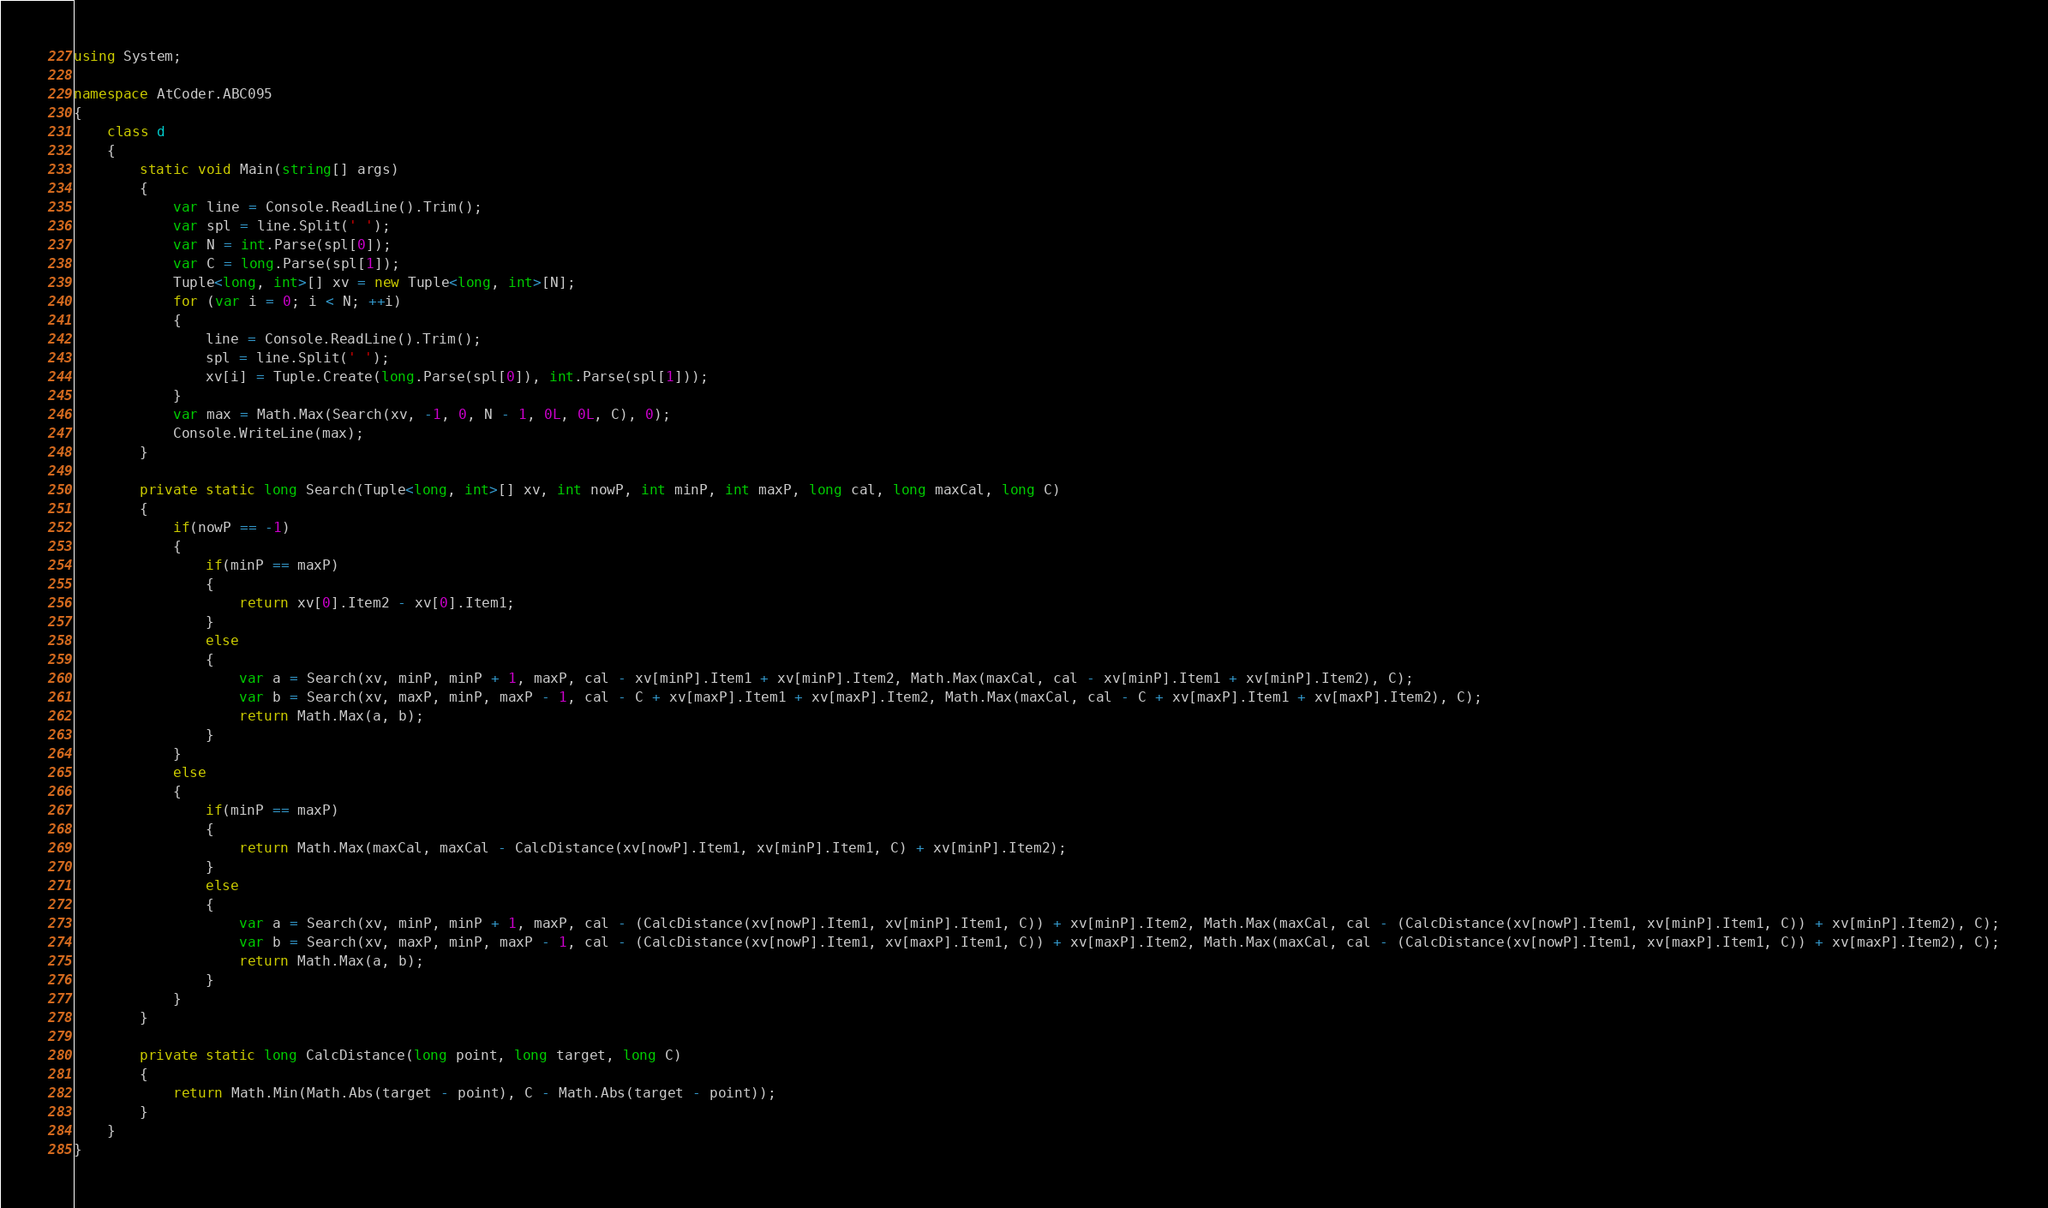<code> <loc_0><loc_0><loc_500><loc_500><_C#_>using System;

namespace AtCoder.ABC095
{
    class d
    {
        static void Main(string[] args)
        {
            var line = Console.ReadLine().Trim();
            var spl = line.Split(' ');
            var N = int.Parse(spl[0]);
            var C = long.Parse(spl[1]);
            Tuple<long, int>[] xv = new Tuple<long, int>[N];
            for (var i = 0; i < N; ++i)
            {
                line = Console.ReadLine().Trim();
                spl = line.Split(' ');
                xv[i] = Tuple.Create(long.Parse(spl[0]), int.Parse(spl[1]));
            }
            var max = Math.Max(Search(xv, -1, 0, N - 1, 0L, 0L, C), 0);
            Console.WriteLine(max);
        }

        private static long Search(Tuple<long, int>[] xv, int nowP, int minP, int maxP, long cal, long maxCal, long C)
        {
            if(nowP == -1)
            {
                if(minP == maxP)
                {
                    return xv[0].Item2 - xv[0].Item1;
                }
                else
                {
                    var a = Search(xv, minP, minP + 1, maxP, cal - xv[minP].Item1 + xv[minP].Item2, Math.Max(maxCal, cal - xv[minP].Item1 + xv[minP].Item2), C);
                    var b = Search(xv, maxP, minP, maxP - 1, cal - C + xv[maxP].Item1 + xv[maxP].Item2, Math.Max(maxCal, cal - C + xv[maxP].Item1 + xv[maxP].Item2), C);
                    return Math.Max(a, b);
                }
            }
            else
            {
                if(minP == maxP)
                {
                    return Math.Max(maxCal, maxCal - CalcDistance(xv[nowP].Item1, xv[minP].Item1, C) + xv[minP].Item2);
                }
                else
                {
                    var a = Search(xv, minP, minP + 1, maxP, cal - (CalcDistance(xv[nowP].Item1, xv[minP].Item1, C)) + xv[minP].Item2, Math.Max(maxCal, cal - (CalcDistance(xv[nowP].Item1, xv[minP].Item1, C)) + xv[minP].Item2), C);
                    var b = Search(xv, maxP, minP, maxP - 1, cal - (CalcDistance(xv[nowP].Item1, xv[maxP].Item1, C)) + xv[maxP].Item2, Math.Max(maxCal, cal - (CalcDistance(xv[nowP].Item1, xv[maxP].Item1, C)) + xv[maxP].Item2), C);
                    return Math.Max(a, b);
                }
            }
        }

        private static long CalcDistance(long point, long target, long C)
        {
            return Math.Min(Math.Abs(target - point), C - Math.Abs(target - point));
        }
    }
}
</code> 